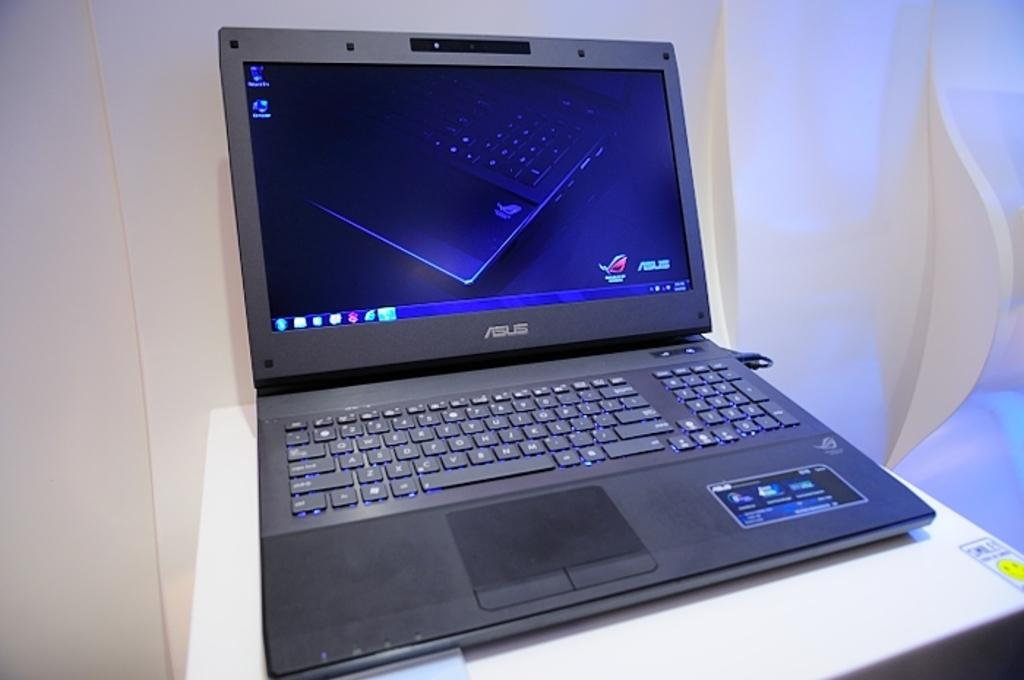What electronic device is visible in the image? There is a laptop in the image. What is the laptop placed on? The laptop is on a white-colored object. What can be seen behind the laptop? There is a wall visible in the background of the image. What suggestion does the laptop make in the image? The laptop does not make any suggestions in the image, as it is an inanimate object. 